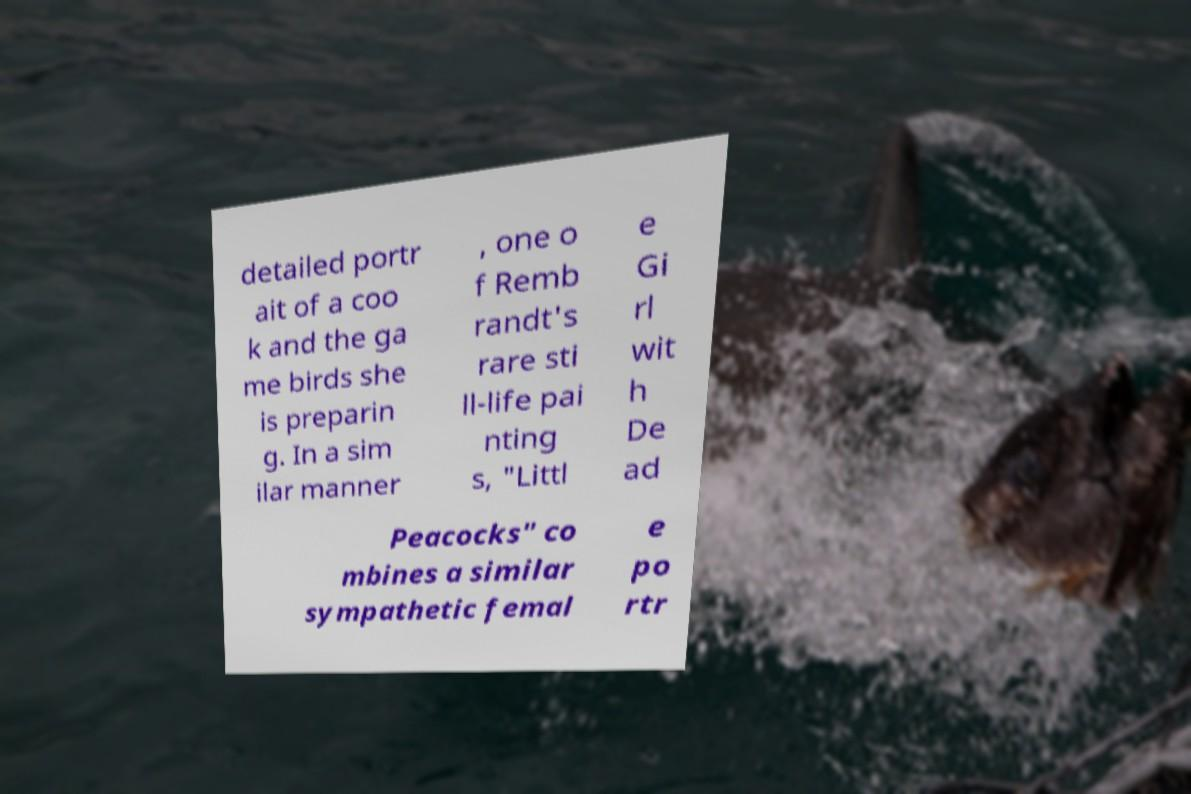For documentation purposes, I need the text within this image transcribed. Could you provide that? detailed portr ait of a coo k and the ga me birds she is preparin g. In a sim ilar manner , one o f Remb randt's rare sti ll-life pai nting s, "Littl e Gi rl wit h De ad Peacocks" co mbines a similar sympathetic femal e po rtr 